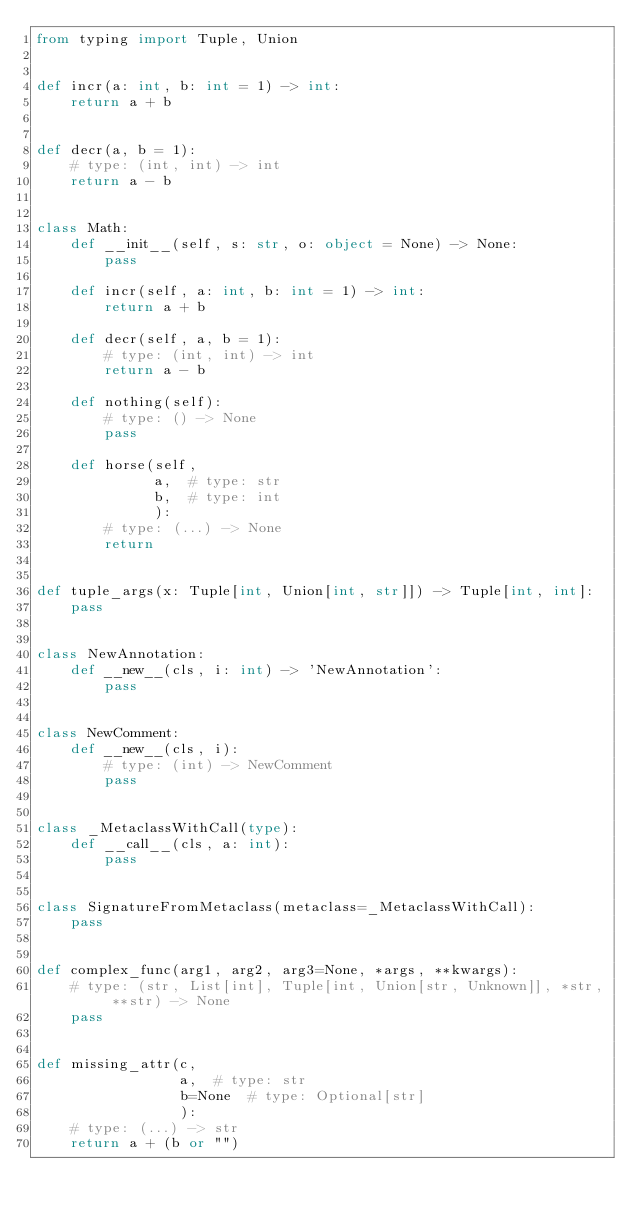Convert code to text. <code><loc_0><loc_0><loc_500><loc_500><_Python_>from typing import Tuple, Union


def incr(a: int, b: int = 1) -> int:
    return a + b


def decr(a, b = 1):
    # type: (int, int) -> int
    return a - b


class Math:
    def __init__(self, s: str, o: object = None) -> None:
        pass

    def incr(self, a: int, b: int = 1) -> int:
        return a + b

    def decr(self, a, b = 1):
        # type: (int, int) -> int
        return a - b

    def nothing(self):
        # type: () -> None
        pass

    def horse(self,
              a,  # type: str
              b,  # type: int
              ):
        # type: (...) -> None
        return


def tuple_args(x: Tuple[int, Union[int, str]]) -> Tuple[int, int]:
    pass


class NewAnnotation:
    def __new__(cls, i: int) -> 'NewAnnotation':
        pass


class NewComment:
    def __new__(cls, i):
        # type: (int) -> NewComment
        pass


class _MetaclassWithCall(type):
    def __call__(cls, a: int):
        pass


class SignatureFromMetaclass(metaclass=_MetaclassWithCall):
    pass


def complex_func(arg1, arg2, arg3=None, *args, **kwargs):
    # type: (str, List[int], Tuple[int, Union[str, Unknown]], *str, **str) -> None
    pass


def missing_attr(c,
                 a,  # type: str
                 b=None  # type: Optional[str]
                 ):
    # type: (...) -> str
    return a + (b or "")
</code> 